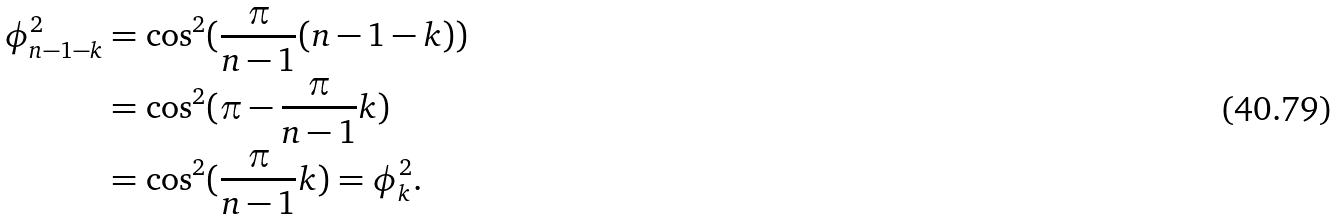Convert formula to latex. <formula><loc_0><loc_0><loc_500><loc_500>\phi ^ { 2 } _ { n - 1 - k } & = \cos ^ { 2 } ( \frac { \pi } { n - 1 } ( n - 1 - k ) ) \\ & = \cos ^ { 2 } ( \pi - \frac { \pi } { n - 1 } k ) \\ & = \cos ^ { 2 } ( \frac { \pi } { n - 1 } k ) = \phi ^ { 2 } _ { k } .</formula> 